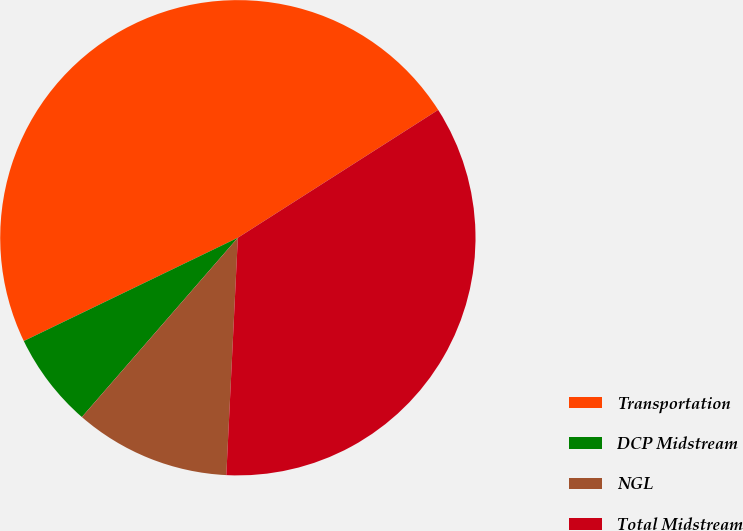Convert chart. <chart><loc_0><loc_0><loc_500><loc_500><pie_chart><fcel>Transportation<fcel>DCP Midstream<fcel>NGL<fcel>Total Midstream<nl><fcel>48.11%<fcel>6.45%<fcel>10.62%<fcel>34.81%<nl></chart> 